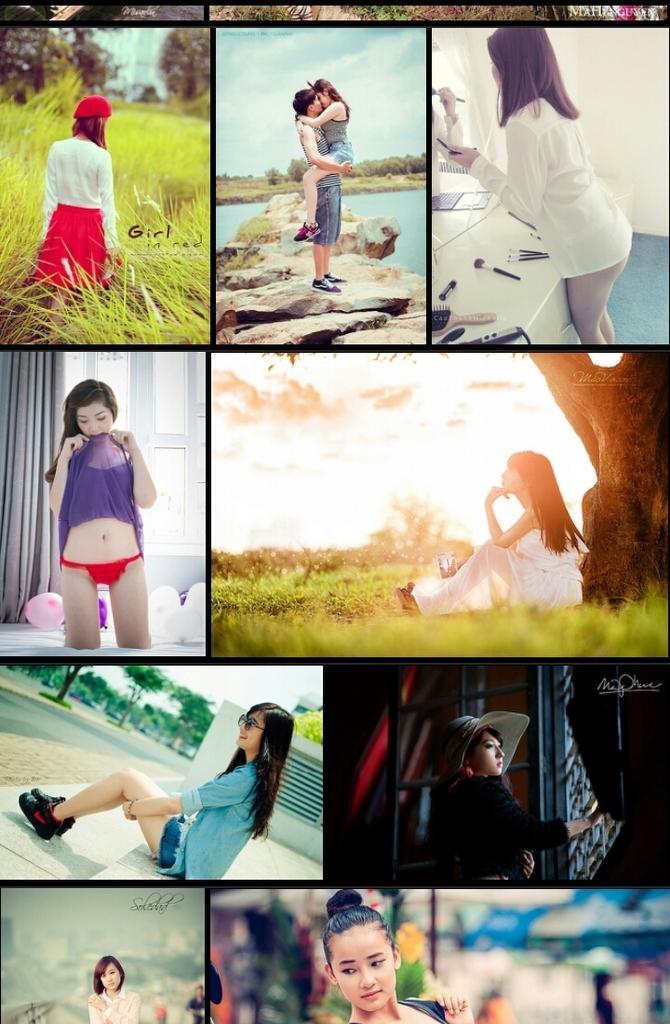Please provide a concise description of this image. This is a collage picture and in this picture we can see a man, some women, water, grass, trees, balloons, rocks, sky with clouds and some objects. 